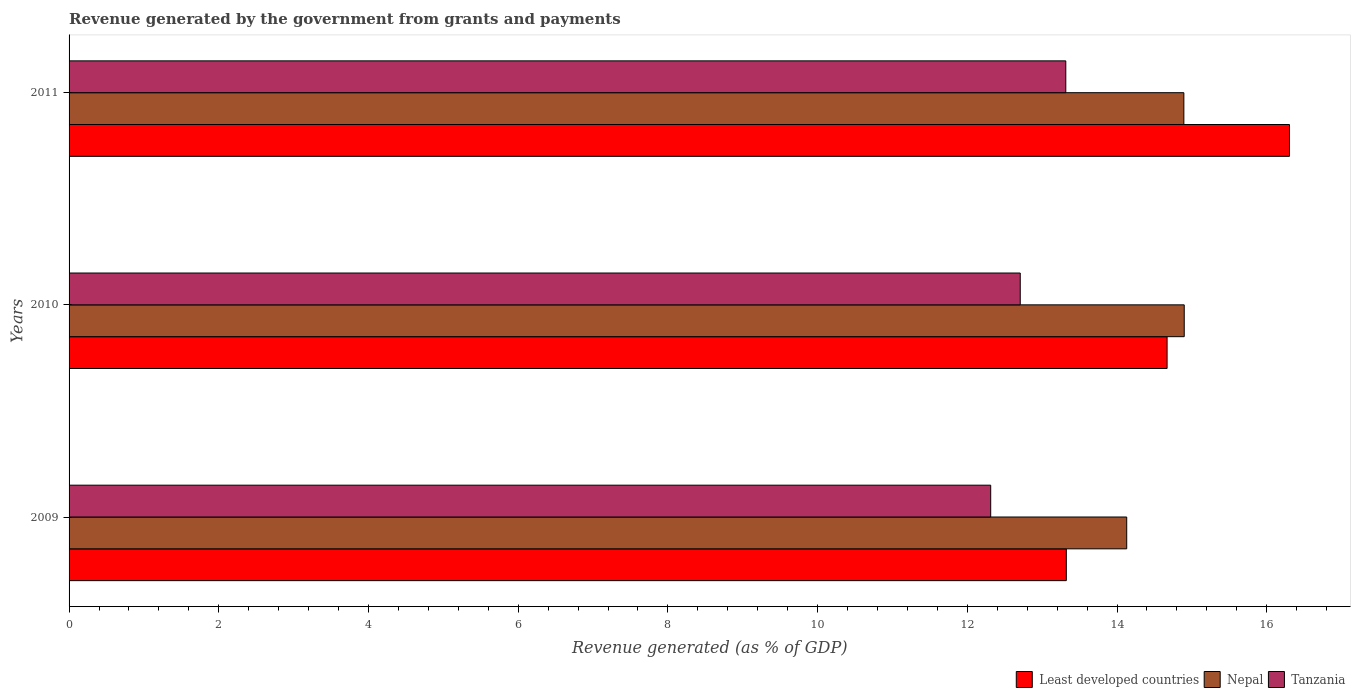How many different coloured bars are there?
Your response must be concise. 3. Are the number of bars per tick equal to the number of legend labels?
Ensure brevity in your answer.  Yes. How many bars are there on the 2nd tick from the top?
Your answer should be very brief. 3. How many bars are there on the 2nd tick from the bottom?
Give a very brief answer. 3. What is the revenue generated by the government in Least developed countries in 2011?
Your answer should be compact. 16.3. Across all years, what is the maximum revenue generated by the government in Nepal?
Your answer should be very brief. 14.9. Across all years, what is the minimum revenue generated by the government in Nepal?
Your answer should be compact. 14.13. What is the total revenue generated by the government in Tanzania in the graph?
Provide a succinct answer. 38.34. What is the difference between the revenue generated by the government in Least developed countries in 2009 and that in 2010?
Offer a very short reply. -1.35. What is the difference between the revenue generated by the government in Tanzania in 2009 and the revenue generated by the government in Least developed countries in 2011?
Ensure brevity in your answer.  -3.99. What is the average revenue generated by the government in Nepal per year?
Give a very brief answer. 14.64. In the year 2011, what is the difference between the revenue generated by the government in Tanzania and revenue generated by the government in Least developed countries?
Your response must be concise. -2.99. What is the ratio of the revenue generated by the government in Least developed countries in 2009 to that in 2011?
Keep it short and to the point. 0.82. Is the revenue generated by the government in Tanzania in 2009 less than that in 2011?
Make the answer very short. Yes. What is the difference between the highest and the second highest revenue generated by the government in Least developed countries?
Your response must be concise. 1.64. What is the difference between the highest and the lowest revenue generated by the government in Least developed countries?
Your answer should be very brief. 2.98. What does the 2nd bar from the top in 2010 represents?
Your answer should be very brief. Nepal. What does the 1st bar from the bottom in 2010 represents?
Provide a short and direct response. Least developed countries. Is it the case that in every year, the sum of the revenue generated by the government in Tanzania and revenue generated by the government in Least developed countries is greater than the revenue generated by the government in Nepal?
Your answer should be very brief. Yes. How many bars are there?
Make the answer very short. 9. Are all the bars in the graph horizontal?
Give a very brief answer. Yes. How many years are there in the graph?
Provide a short and direct response. 3. Does the graph contain grids?
Your answer should be compact. No. How are the legend labels stacked?
Provide a short and direct response. Horizontal. What is the title of the graph?
Provide a succinct answer. Revenue generated by the government from grants and payments. What is the label or title of the X-axis?
Your answer should be very brief. Revenue generated (as % of GDP). What is the Revenue generated (as % of GDP) in Least developed countries in 2009?
Ensure brevity in your answer.  13.32. What is the Revenue generated (as % of GDP) of Nepal in 2009?
Provide a succinct answer. 14.13. What is the Revenue generated (as % of GDP) of Tanzania in 2009?
Make the answer very short. 12.31. What is the Revenue generated (as % of GDP) in Least developed countries in 2010?
Provide a short and direct response. 14.67. What is the Revenue generated (as % of GDP) of Nepal in 2010?
Keep it short and to the point. 14.9. What is the Revenue generated (as % of GDP) of Tanzania in 2010?
Ensure brevity in your answer.  12.71. What is the Revenue generated (as % of GDP) in Least developed countries in 2011?
Your answer should be very brief. 16.3. What is the Revenue generated (as % of GDP) in Nepal in 2011?
Keep it short and to the point. 14.89. What is the Revenue generated (as % of GDP) of Tanzania in 2011?
Provide a short and direct response. 13.32. Across all years, what is the maximum Revenue generated (as % of GDP) in Least developed countries?
Offer a terse response. 16.3. Across all years, what is the maximum Revenue generated (as % of GDP) of Nepal?
Offer a very short reply. 14.9. Across all years, what is the maximum Revenue generated (as % of GDP) in Tanzania?
Your response must be concise. 13.32. Across all years, what is the minimum Revenue generated (as % of GDP) of Least developed countries?
Make the answer very short. 13.32. Across all years, what is the minimum Revenue generated (as % of GDP) in Nepal?
Offer a very short reply. 14.13. Across all years, what is the minimum Revenue generated (as % of GDP) of Tanzania?
Your answer should be very brief. 12.31. What is the total Revenue generated (as % of GDP) of Least developed countries in the graph?
Your answer should be very brief. 44.3. What is the total Revenue generated (as % of GDP) in Nepal in the graph?
Keep it short and to the point. 43.92. What is the total Revenue generated (as % of GDP) in Tanzania in the graph?
Make the answer very short. 38.34. What is the difference between the Revenue generated (as % of GDP) in Least developed countries in 2009 and that in 2010?
Keep it short and to the point. -1.35. What is the difference between the Revenue generated (as % of GDP) in Nepal in 2009 and that in 2010?
Make the answer very short. -0.77. What is the difference between the Revenue generated (as % of GDP) of Tanzania in 2009 and that in 2010?
Make the answer very short. -0.39. What is the difference between the Revenue generated (as % of GDP) in Least developed countries in 2009 and that in 2011?
Give a very brief answer. -2.98. What is the difference between the Revenue generated (as % of GDP) in Nepal in 2009 and that in 2011?
Offer a terse response. -0.76. What is the difference between the Revenue generated (as % of GDP) in Tanzania in 2009 and that in 2011?
Offer a very short reply. -1. What is the difference between the Revenue generated (as % of GDP) of Least developed countries in 2010 and that in 2011?
Your response must be concise. -1.64. What is the difference between the Revenue generated (as % of GDP) of Nepal in 2010 and that in 2011?
Your response must be concise. 0.01. What is the difference between the Revenue generated (as % of GDP) of Tanzania in 2010 and that in 2011?
Ensure brevity in your answer.  -0.61. What is the difference between the Revenue generated (as % of GDP) in Least developed countries in 2009 and the Revenue generated (as % of GDP) in Nepal in 2010?
Keep it short and to the point. -1.58. What is the difference between the Revenue generated (as % of GDP) of Least developed countries in 2009 and the Revenue generated (as % of GDP) of Tanzania in 2010?
Provide a short and direct response. 0.62. What is the difference between the Revenue generated (as % of GDP) of Nepal in 2009 and the Revenue generated (as % of GDP) of Tanzania in 2010?
Offer a terse response. 1.42. What is the difference between the Revenue generated (as % of GDP) in Least developed countries in 2009 and the Revenue generated (as % of GDP) in Nepal in 2011?
Provide a succinct answer. -1.57. What is the difference between the Revenue generated (as % of GDP) in Least developed countries in 2009 and the Revenue generated (as % of GDP) in Tanzania in 2011?
Ensure brevity in your answer.  0.01. What is the difference between the Revenue generated (as % of GDP) of Nepal in 2009 and the Revenue generated (as % of GDP) of Tanzania in 2011?
Make the answer very short. 0.81. What is the difference between the Revenue generated (as % of GDP) in Least developed countries in 2010 and the Revenue generated (as % of GDP) in Nepal in 2011?
Offer a terse response. -0.22. What is the difference between the Revenue generated (as % of GDP) in Least developed countries in 2010 and the Revenue generated (as % of GDP) in Tanzania in 2011?
Provide a succinct answer. 1.35. What is the difference between the Revenue generated (as % of GDP) in Nepal in 2010 and the Revenue generated (as % of GDP) in Tanzania in 2011?
Make the answer very short. 1.58. What is the average Revenue generated (as % of GDP) in Least developed countries per year?
Keep it short and to the point. 14.77. What is the average Revenue generated (as % of GDP) in Nepal per year?
Keep it short and to the point. 14.64. What is the average Revenue generated (as % of GDP) in Tanzania per year?
Give a very brief answer. 12.78. In the year 2009, what is the difference between the Revenue generated (as % of GDP) of Least developed countries and Revenue generated (as % of GDP) of Nepal?
Provide a succinct answer. -0.81. In the year 2009, what is the difference between the Revenue generated (as % of GDP) in Least developed countries and Revenue generated (as % of GDP) in Tanzania?
Keep it short and to the point. 1.01. In the year 2009, what is the difference between the Revenue generated (as % of GDP) of Nepal and Revenue generated (as % of GDP) of Tanzania?
Offer a very short reply. 1.82. In the year 2010, what is the difference between the Revenue generated (as % of GDP) of Least developed countries and Revenue generated (as % of GDP) of Nepal?
Offer a very short reply. -0.23. In the year 2010, what is the difference between the Revenue generated (as % of GDP) in Least developed countries and Revenue generated (as % of GDP) in Tanzania?
Ensure brevity in your answer.  1.96. In the year 2010, what is the difference between the Revenue generated (as % of GDP) of Nepal and Revenue generated (as % of GDP) of Tanzania?
Ensure brevity in your answer.  2.19. In the year 2011, what is the difference between the Revenue generated (as % of GDP) in Least developed countries and Revenue generated (as % of GDP) in Nepal?
Keep it short and to the point. 1.41. In the year 2011, what is the difference between the Revenue generated (as % of GDP) of Least developed countries and Revenue generated (as % of GDP) of Tanzania?
Provide a succinct answer. 2.99. In the year 2011, what is the difference between the Revenue generated (as % of GDP) in Nepal and Revenue generated (as % of GDP) in Tanzania?
Keep it short and to the point. 1.58. What is the ratio of the Revenue generated (as % of GDP) of Least developed countries in 2009 to that in 2010?
Offer a very short reply. 0.91. What is the ratio of the Revenue generated (as % of GDP) in Nepal in 2009 to that in 2010?
Make the answer very short. 0.95. What is the ratio of the Revenue generated (as % of GDP) in Tanzania in 2009 to that in 2010?
Make the answer very short. 0.97. What is the ratio of the Revenue generated (as % of GDP) of Least developed countries in 2009 to that in 2011?
Your answer should be compact. 0.82. What is the ratio of the Revenue generated (as % of GDP) of Nepal in 2009 to that in 2011?
Offer a terse response. 0.95. What is the ratio of the Revenue generated (as % of GDP) of Tanzania in 2009 to that in 2011?
Your answer should be compact. 0.92. What is the ratio of the Revenue generated (as % of GDP) of Least developed countries in 2010 to that in 2011?
Your answer should be compact. 0.9. What is the ratio of the Revenue generated (as % of GDP) of Tanzania in 2010 to that in 2011?
Make the answer very short. 0.95. What is the difference between the highest and the second highest Revenue generated (as % of GDP) of Least developed countries?
Make the answer very short. 1.64. What is the difference between the highest and the second highest Revenue generated (as % of GDP) in Nepal?
Keep it short and to the point. 0.01. What is the difference between the highest and the second highest Revenue generated (as % of GDP) of Tanzania?
Keep it short and to the point. 0.61. What is the difference between the highest and the lowest Revenue generated (as % of GDP) of Least developed countries?
Ensure brevity in your answer.  2.98. What is the difference between the highest and the lowest Revenue generated (as % of GDP) in Nepal?
Ensure brevity in your answer.  0.77. 